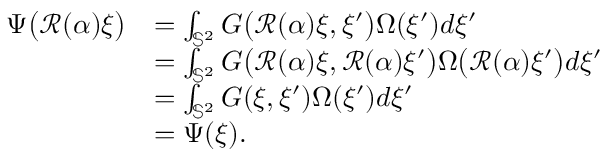Convert formula to latex. <formula><loc_0><loc_0><loc_500><loc_500>\begin{array} { r l } { \Psi \left ( \mathcal { R } ( \alpha ) \xi \right ) } & { = \int _ { \mathbb { S } ^ { 2 } } G \left ( \mathcal { R } ( \alpha ) \xi , \xi ^ { \prime } \right ) \Omega ( \xi ^ { \prime } ) d \xi ^ { \prime } } \\ & { = \int _ { \mathbb { S } ^ { 2 } } G \left ( \mathcal { R } ( \alpha ) \xi , \mathcal { R } ( \alpha ) \xi ^ { \prime } \right ) \Omega \left ( \mathcal { R } ( \alpha ) \xi ^ { \prime } \right ) d \xi ^ { \prime } } \\ & { = \int _ { \mathbb { S } ^ { 2 } } G ( \xi , \xi ^ { \prime } ) \Omega ( \xi ^ { \prime } ) d \xi ^ { \prime } } \\ & { = \Psi ( \xi ) . } \end{array}</formula> 